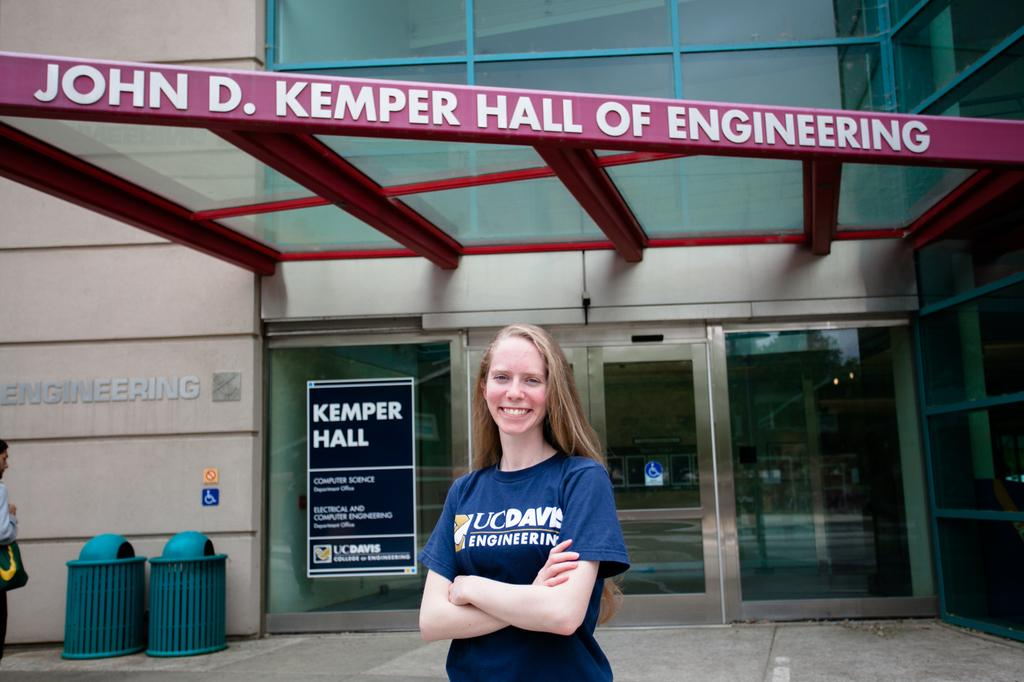Provide a one-sentence caption for the provided image. Girl is standing in front of John D. Kemper Hall of Engineering. 